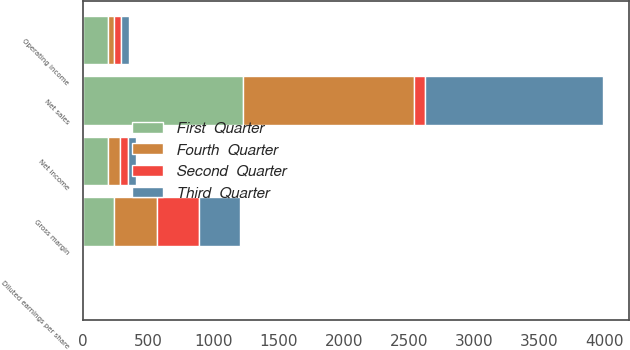Convert chart to OTSL. <chart><loc_0><loc_0><loc_500><loc_500><stacked_bar_chart><ecel><fcel>Net sales<fcel>Gross margin<fcel>Operating income<fcel>Net income<fcel>Diluted earnings per share<nl><fcel>Third  Quarter<fcel>1362<fcel>311<fcel>62<fcel>63<fcel>0.09<nl><fcel>First  Quarter<fcel>1225<fcel>236<fcel>188<fcel>193<fcel>0.27<nl><fcel>Fourth  Quarter<fcel>1312<fcel>329<fcel>47<fcel>88<fcel>0.12<nl><fcel>Second  Quarter<fcel>88<fcel>324<fcel>53<fcel>64<fcel>0.08<nl></chart> 